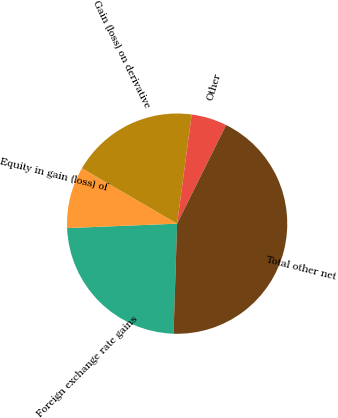<chart> <loc_0><loc_0><loc_500><loc_500><pie_chart><fcel>Foreign exchange rate gains<fcel>Equity in gain (loss) of<fcel>Gain (loss) on derivative<fcel>Other<fcel>Total other net<nl><fcel>23.85%<fcel>9.03%<fcel>18.72%<fcel>5.23%<fcel>43.18%<nl></chart> 